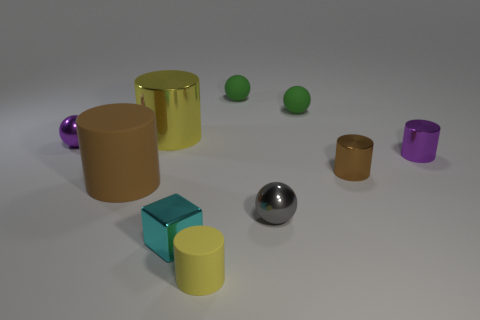Subtract 2 cylinders. How many cylinders are left? 3 Subtract all brown rubber cylinders. How many cylinders are left? 4 Subtract all purple cylinders. How many cylinders are left? 4 Subtract all gray cylinders. Subtract all purple spheres. How many cylinders are left? 5 Subtract all balls. How many objects are left? 6 Add 5 big brown cylinders. How many big brown cylinders exist? 6 Subtract 0 gray cylinders. How many objects are left? 10 Subtract all large brown objects. Subtract all yellow spheres. How many objects are left? 9 Add 7 big things. How many big things are left? 9 